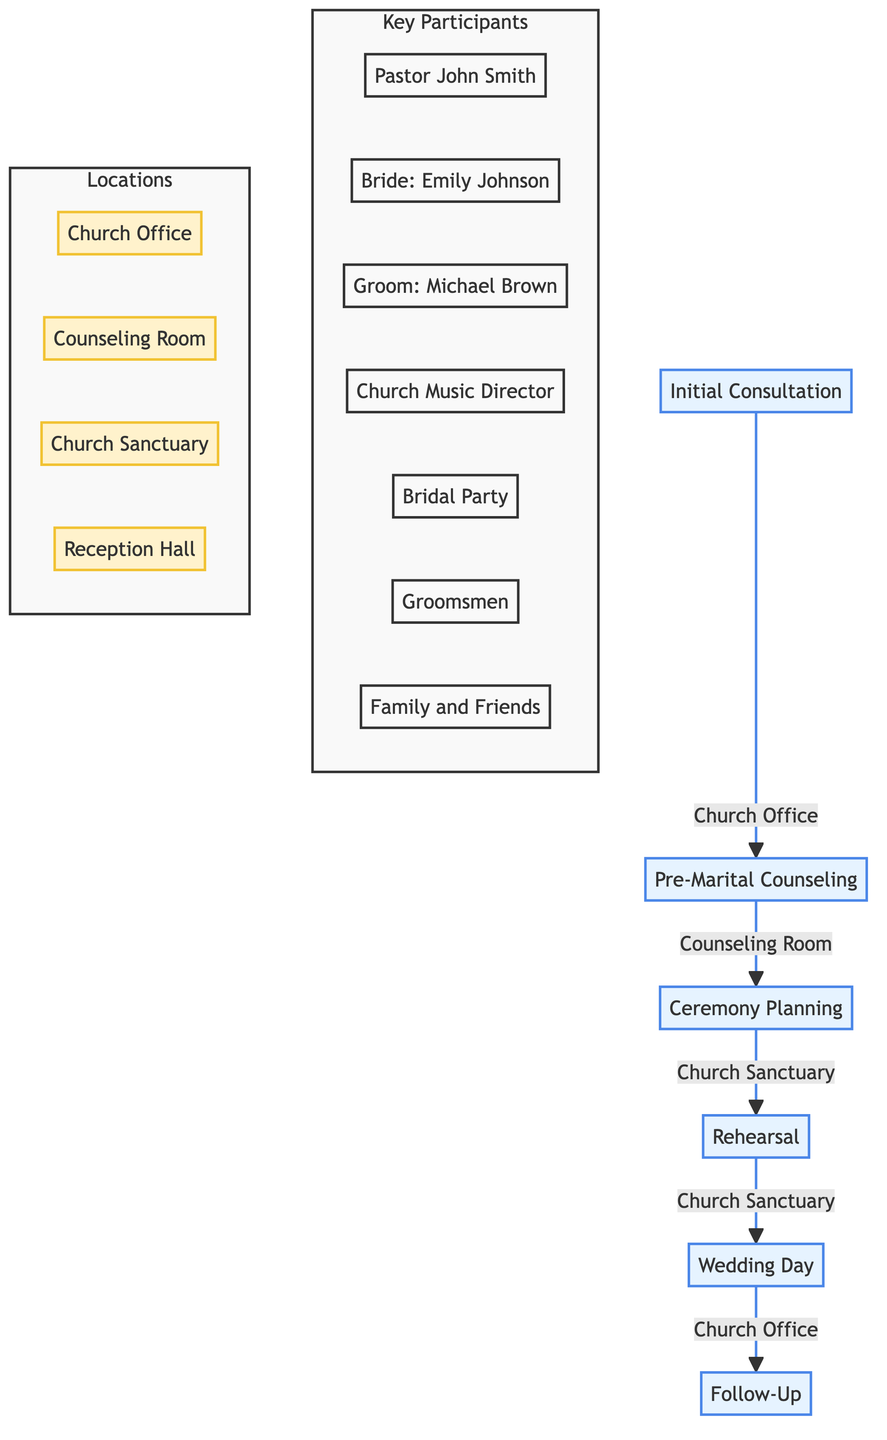What is the first step in the wedding service planning? The first step shown in the diagram is "Initial Consultation." It is the starting point of the clinical pathway.
Answer: Initial Consultation How many key participants are involved in the "Wedding Day"? To find the number of key participants in "Wedding Day," we identify the participants listed: Pastor John Smith, Bridal Party, Groomsmen, Family and Friends. That totals four distinct groups/roles.
Answer: 4 What location is associated with "Pre-Marital Counseling"? The diagram specifies "Counseling Room" as the location for "Pre-Marital Counseling." It is the designated area for this step.
Answer: Counseling Room Which step comes immediately after "Rehearsal"? By following the sequence in the diagram, "Wedding Day" is the step that comes right after "Rehearsal." It directly follows in the workflow.
Answer: Wedding Day How many steps are there in the entire clinical pathway? Counting the steps provided in the section of the diagram reveals there are six steps in total: Initial Consultation, Pre-Marital Counseling, Ceremony Planning, Rehearsal, Wedding Day, and Follow-Up.
Answer: 6 Who is the key participant in the “Ceremony Planning” step besides the couple? The "Ceremony Planning" step lists a key participant alongside the couple as "Church Music Director." This provides an additional participant involved in that step.
Answer: Church Music Director What role does Pastor John Smith play in the wedding service planning? Pastor John Smith is involved in every step of the clinical pathway, serving as the pastor overseeing the entire wedding service planning and execution process.
Answer: Overseer Which steps take place in the "Church Sanctuary"? The steps that occur in the "Church Sanctuary" are "Ceremony Planning," "Rehearsal," and "Wedding Day," as indicated in the details of those specific steps.
Answer: Ceremony Planning, Rehearsal, Wedding Day What is the purpose of the "Follow-Up" step? The explanation of the "Follow-Up" step indicates it aims to provide spiritual guidance and support to the couple after the ceremony. This step is focused on their ongoing relationship.
Answer: Spiritual guidance and support 